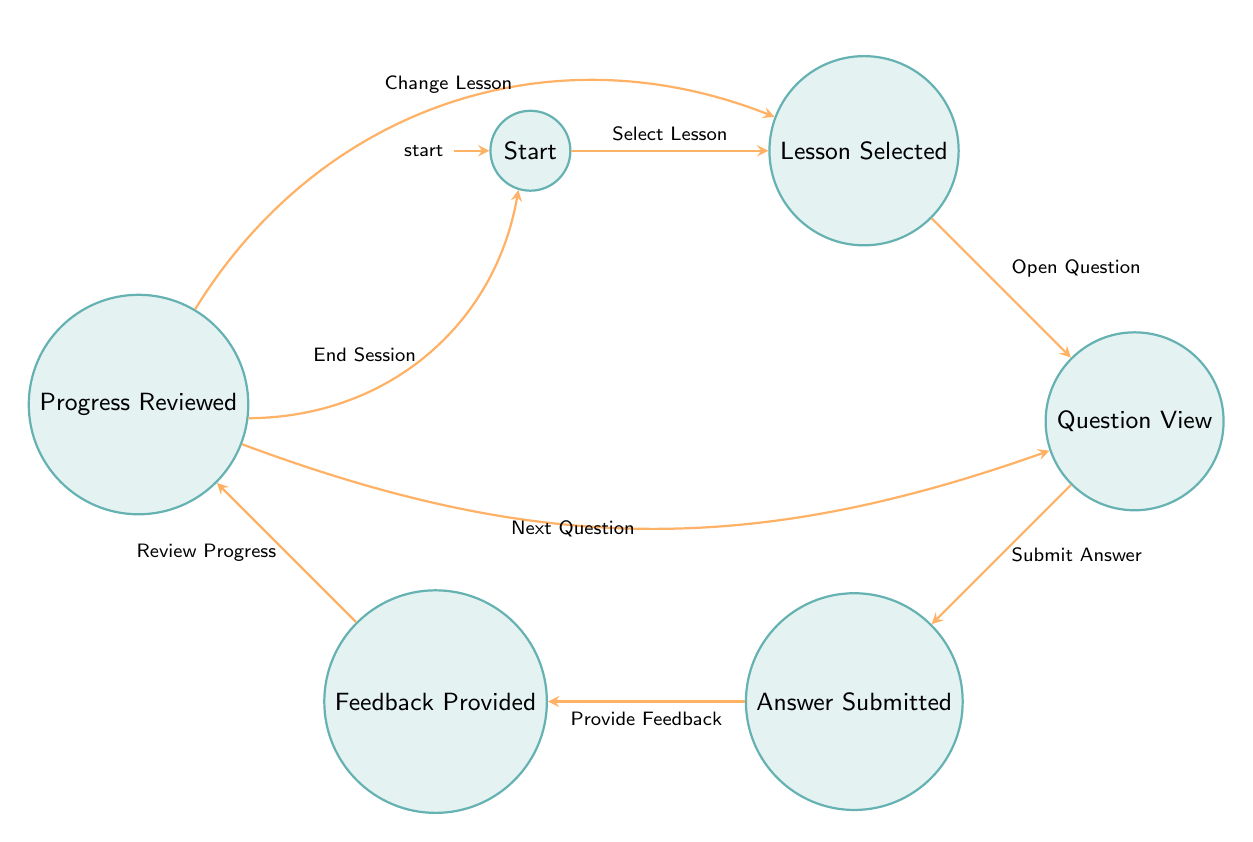What is the initial state of the machine? The initial state is defined directly in the data as "start." This information indicates where the machine begins its operation before any transitions are made.
Answer: start How many states are in the diagram? The data provides a list of states. Counting these, we find six distinct states: Start, Lesson Selected, Question View, Answer Submitted, Feedback Provided, and Progress Reviewed.
Answer: 6 What transition occurs after "Answer Submitted"? Following the "Answer Submitted" state, the next transition is labeled "Provide Feedback," which directs the flow to the "Feedback Provided" state. This indicates the logical progression after submitting an answer.
Answer: Provide Feedback Which state comes after "Lesson Selected"? The state that follows "Lesson Selected" is "Question View," as indicated by the transition named "Open Question." This shows the next step in the sequence after selecting a lesson.
Answer: Question View What can you do after "Progress Reviewed"? After "Progress Reviewed," there are three possible transitions: "Next Question" leads back to "Question View," "Change Lesson" leads to "Lesson Selected," and "End Session" returns to "Start." This represents the options available at that stage of the flow.
Answer: Next Question, Change Lesson, End Session What is the relationship between "Feedback Provided" and "Progress Reviewed"? The relationship is indicated by the transition named "Review Progress," which connects "Feedback Provided" directly to "Progress Reviewed." This signifies that reviewing progress comes after receiving feedback.
Answer: Review Progress Which state indicates the end of the session? The "start" state is the end of the session, as indicated by the transition labeled "End Session," which directs the flow back to "start" from the "Progress Reviewed" state. This marks the conclusion of the operations.
Answer: start 